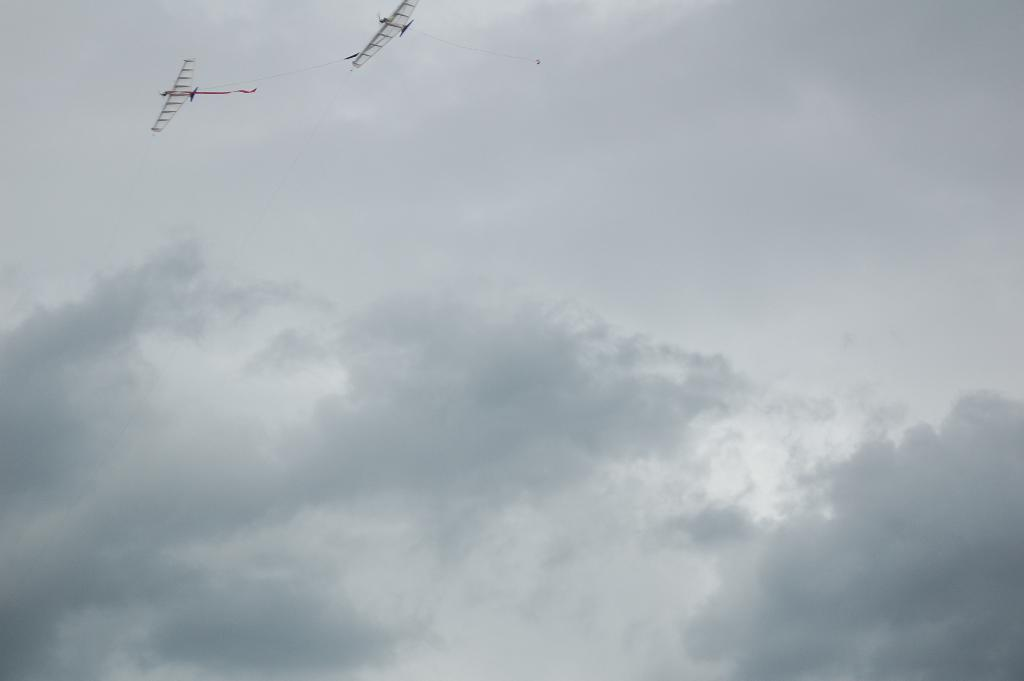What objects in the image resemble kites? There are objects in the image that resemble kites. Where are the kite-like objects located in the image? The kites are flying in the sky. What is the opinion of the shoe in the image? There is no shoe present in the image, so it is not possible to determine its opinion. 